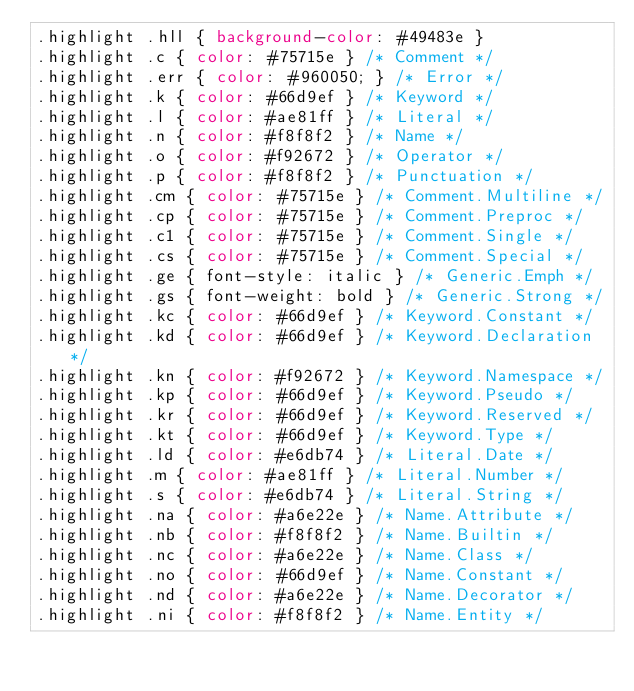Convert code to text. <code><loc_0><loc_0><loc_500><loc_500><_CSS_>.highlight .hll { background-color: #49483e }
.highlight .c { color: #75715e } /* Comment */
.highlight .err { color: #960050; } /* Error */
.highlight .k { color: #66d9ef } /* Keyword */
.highlight .l { color: #ae81ff } /* Literal */
.highlight .n { color: #f8f8f2 } /* Name */
.highlight .o { color: #f92672 } /* Operator */
.highlight .p { color: #f8f8f2 } /* Punctuation */
.highlight .cm { color: #75715e } /* Comment.Multiline */
.highlight .cp { color: #75715e } /* Comment.Preproc */
.highlight .c1 { color: #75715e } /* Comment.Single */
.highlight .cs { color: #75715e } /* Comment.Special */
.highlight .ge { font-style: italic } /* Generic.Emph */
.highlight .gs { font-weight: bold } /* Generic.Strong */
.highlight .kc { color: #66d9ef } /* Keyword.Constant */
.highlight .kd { color: #66d9ef } /* Keyword.Declaration */
.highlight .kn { color: #f92672 } /* Keyword.Namespace */
.highlight .kp { color: #66d9ef } /* Keyword.Pseudo */
.highlight .kr { color: #66d9ef } /* Keyword.Reserved */
.highlight .kt { color: #66d9ef } /* Keyword.Type */
.highlight .ld { color: #e6db74 } /* Literal.Date */
.highlight .m { color: #ae81ff } /* Literal.Number */
.highlight .s { color: #e6db74 } /* Literal.String */
.highlight .na { color: #a6e22e } /* Name.Attribute */
.highlight .nb { color: #f8f8f2 } /* Name.Builtin */
.highlight .nc { color: #a6e22e } /* Name.Class */
.highlight .no { color: #66d9ef } /* Name.Constant */
.highlight .nd { color: #a6e22e } /* Name.Decorator */
.highlight .ni { color: #f8f8f2 } /* Name.Entity */</code> 